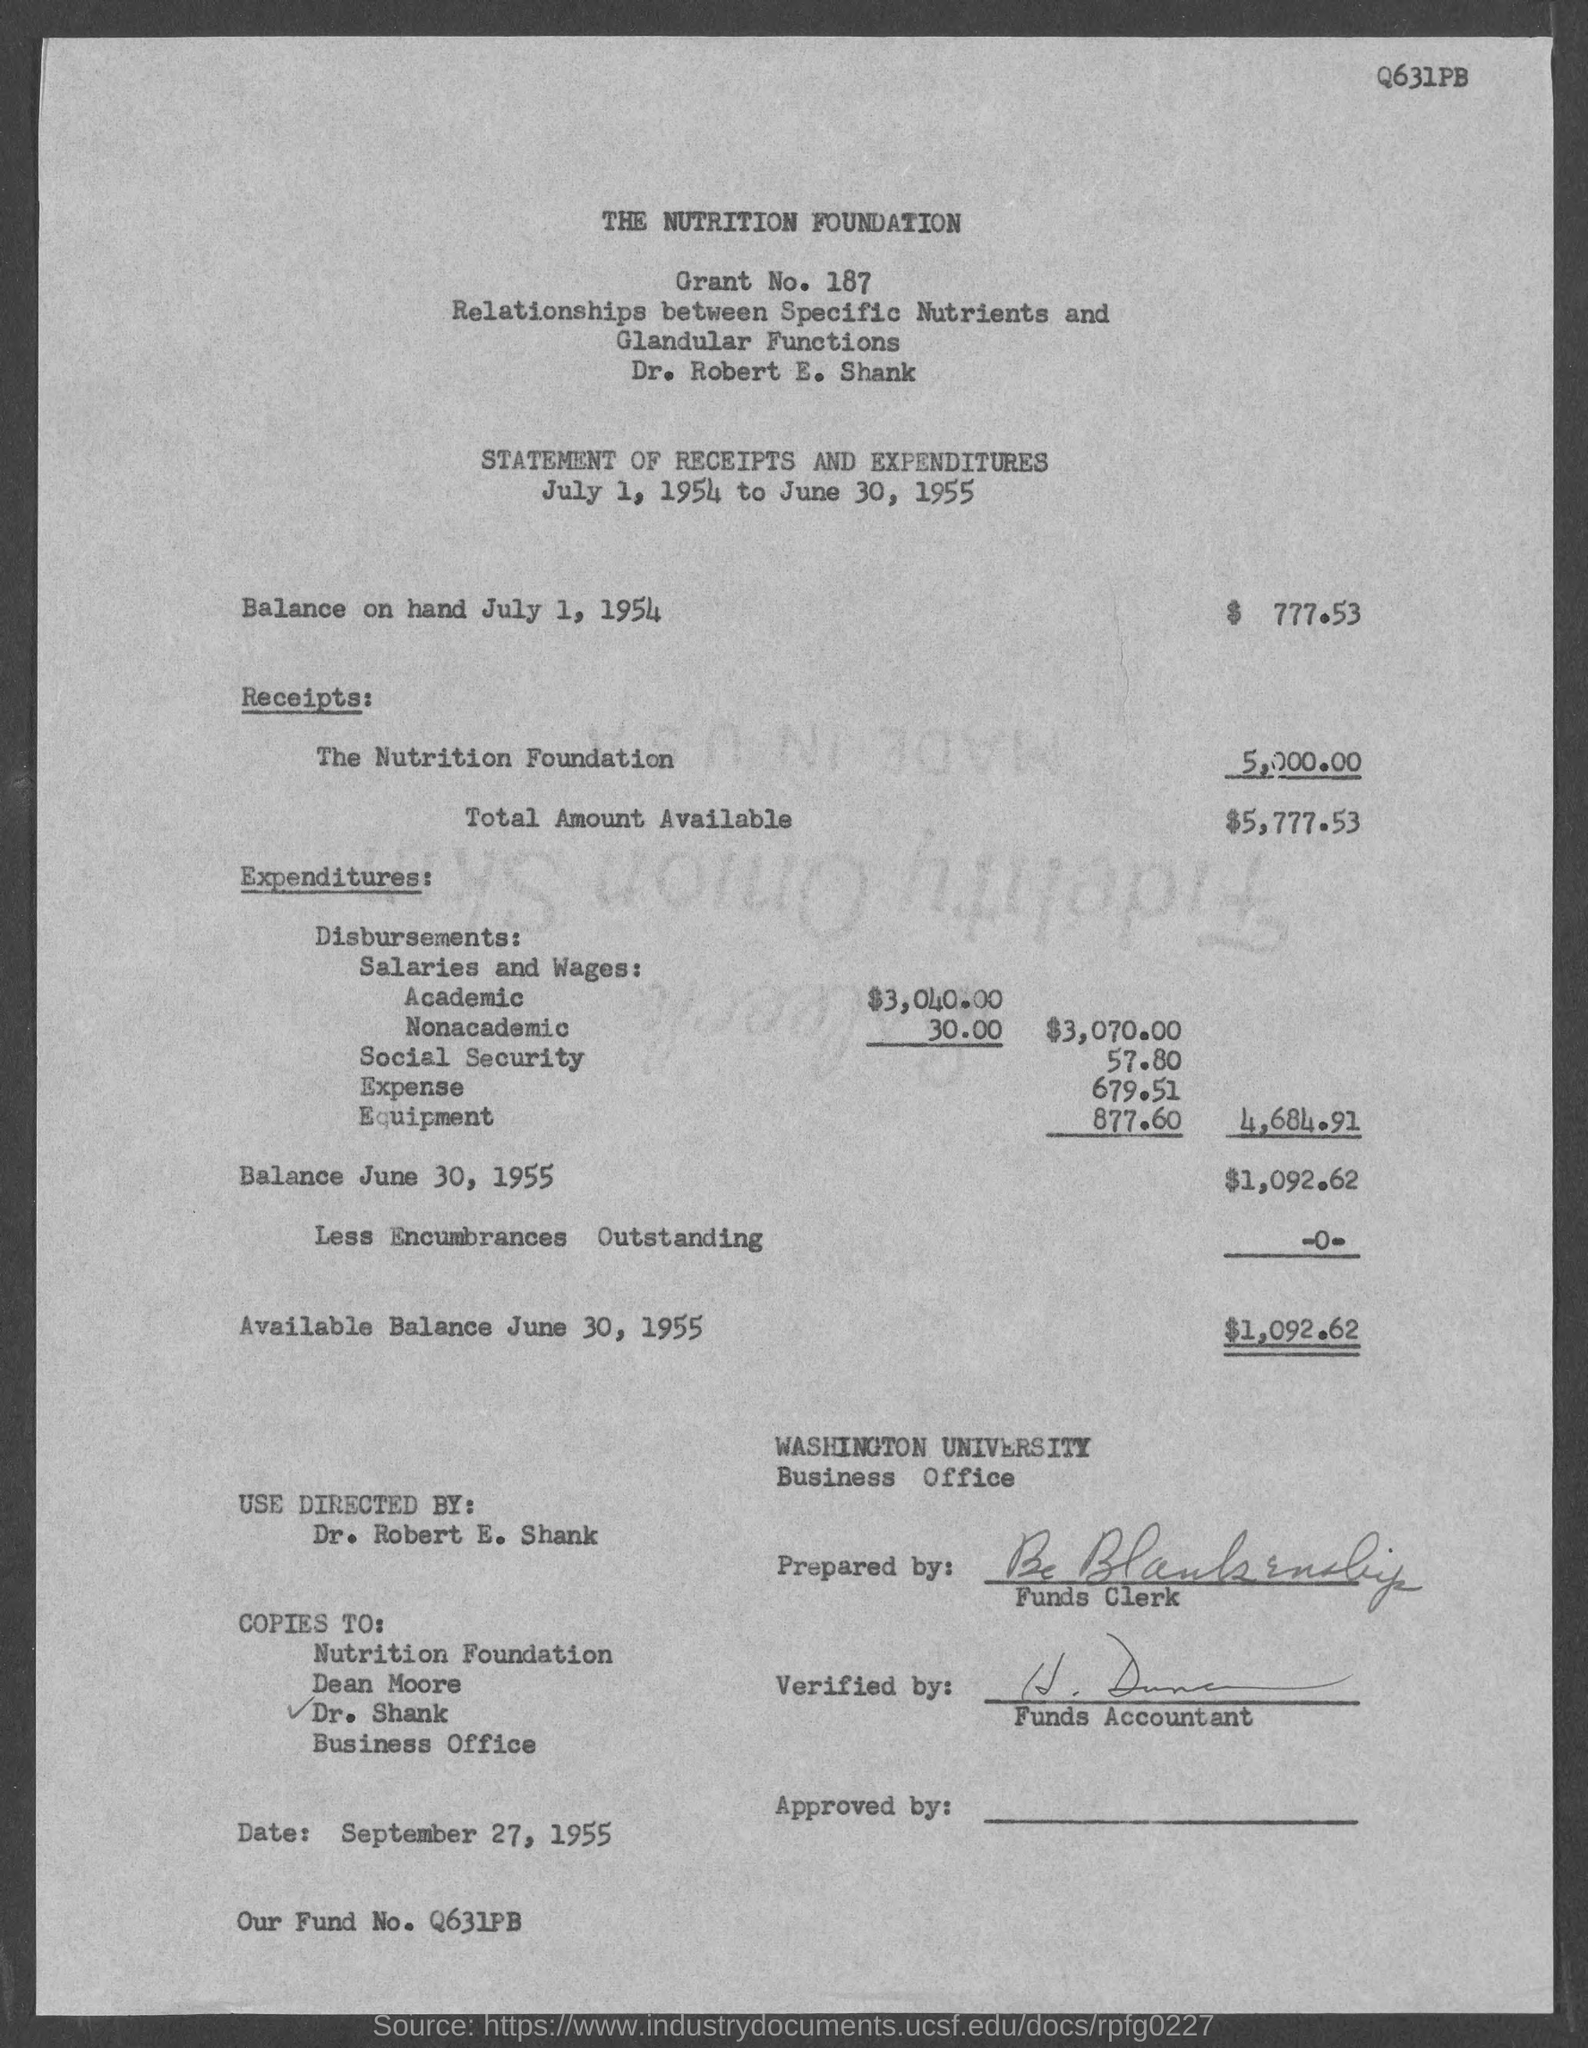Draw attention to some important aspects in this diagram. What is the fund number? Q631PB...," is a question asking for information about a specific fund number. Washington University is the name of the university. The total amount available is $5,777.53. The name of the company is The Nutrition Foundation. The balance on hand by July 1, 1954 was 777.53 dollars. 